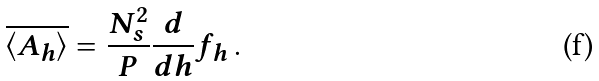Convert formula to latex. <formula><loc_0><loc_0><loc_500><loc_500>\overline { \langle A _ { h } \rangle } = \frac { N _ { s } ^ { 2 } } { P } \frac { d } { d h } f _ { h } \, .</formula> 